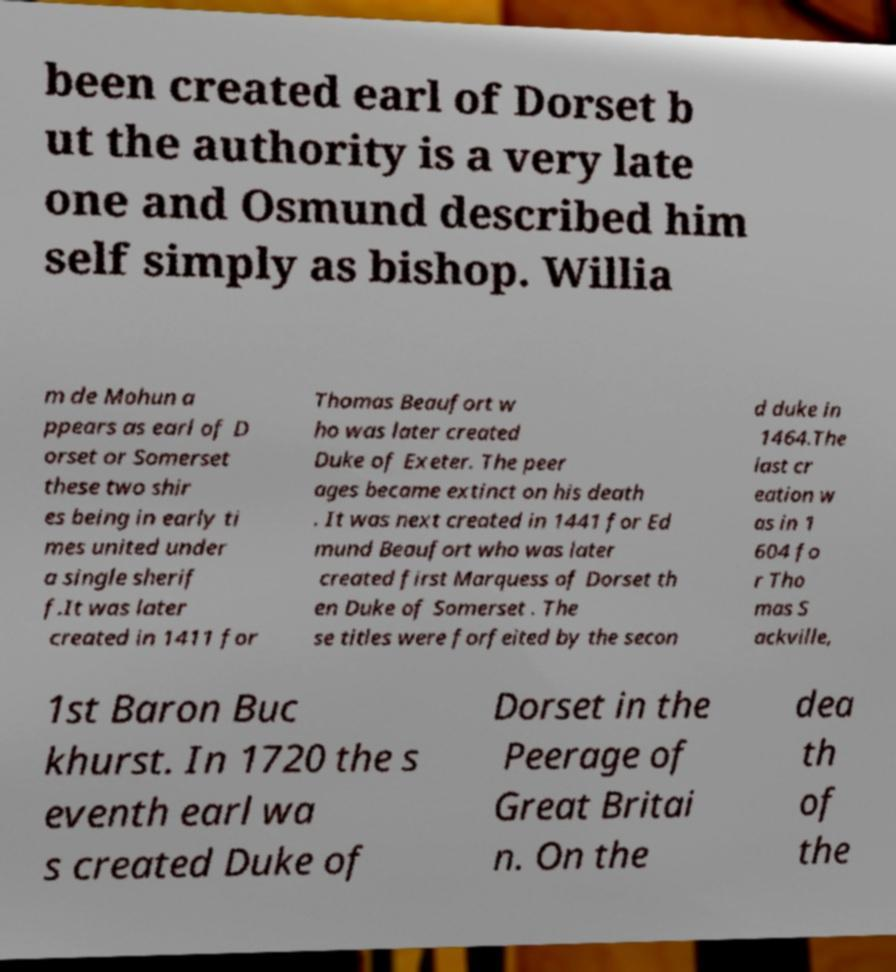Can you accurately transcribe the text from the provided image for me? been created earl of Dorset b ut the authority is a very late one and Osmund described him self simply as bishop. Willia m de Mohun a ppears as earl of D orset or Somerset these two shir es being in early ti mes united under a single sherif f.It was later created in 1411 for Thomas Beaufort w ho was later created Duke of Exeter. The peer ages became extinct on his death . It was next created in 1441 for Ed mund Beaufort who was later created first Marquess of Dorset th en Duke of Somerset . The se titles were forfeited by the secon d duke in 1464.The last cr eation w as in 1 604 fo r Tho mas S ackville, 1st Baron Buc khurst. In 1720 the s eventh earl wa s created Duke of Dorset in the Peerage of Great Britai n. On the dea th of the 